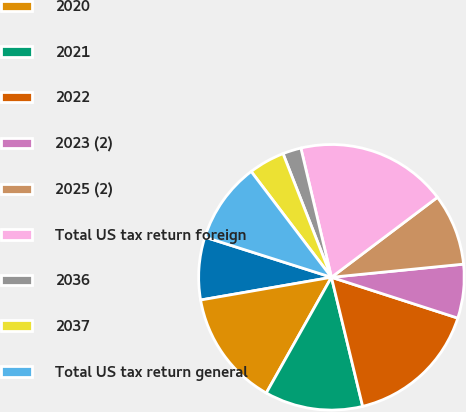Convert chart to OTSL. <chart><loc_0><loc_0><loc_500><loc_500><pie_chart><fcel>2019<fcel>2020<fcel>2021<fcel>2022<fcel>2023 (2)<fcel>2025 (2)<fcel>Total US tax return foreign<fcel>2036<fcel>2037<fcel>Total US tax return general<nl><fcel>7.63%<fcel>14.1%<fcel>11.94%<fcel>16.25%<fcel>6.55%<fcel>8.71%<fcel>18.41%<fcel>2.24%<fcel>4.39%<fcel>9.78%<nl></chart> 